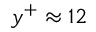<formula> <loc_0><loc_0><loc_500><loc_500>y ^ { + } \approx 1 2</formula> 